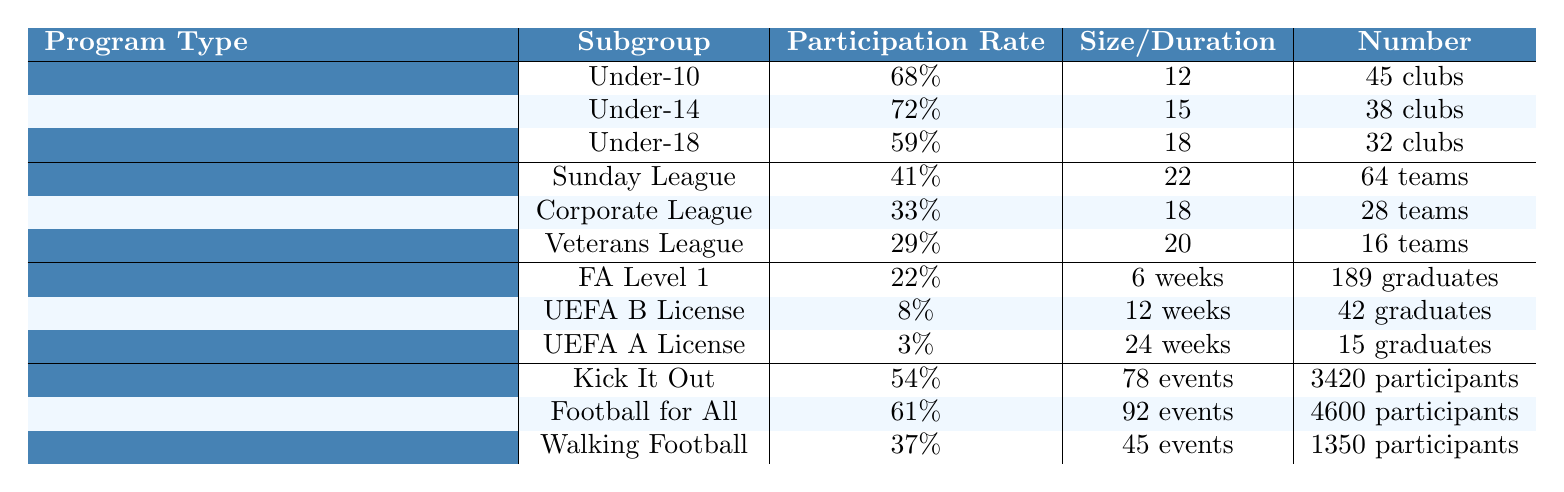What is the participation rate for Under-14 in Youth Development Academies? The table indicates that the participation rate for Under-14 is listed directly under the Youth Development Academies section. According to the table, it is 72%.
Answer: 72% Which program type has the highest participation rate for adults? Upon reviewing the Adult Recreational Leagues, the Sunday League has the highest participation rate at 41%. The rates for Corporate League and Veterans League are lower, at 33% and 29%, respectively.
Answer: Sunday League How many graduates achieved the FA Level 1 in Coaching Certification Programs? The table shows that the number of graduates for FA Level 1 is 189, as this information is explicitly listed under the Coaching Certification Programs section.
Answer: 189 What is the average participation rate of the Community Outreach Initiatives? The participation rates for the programs are Kick It Out (54%), Football for All (61%), and Walking Football (37%). To find the average, we sum these rates: 54 + 61 + 37 = 152, and then divide by 3, giving us an average of 152/3 = 50.67%.
Answer: 50.67% Which division in Adult Recreational Leagues has the lowest average team size? The table specifies the average team sizes: Sunday League 22, Corporate League 18, and Veterans League 20. Comparing these, the Corporate League has the lowest average team size of 18.
Answer: Corporate League Is the participation rate for UEFA A License higher than that of the UEFA B License? According to the table, the participation rate for UEFA A License is 3% while for UEFA B License it is 8%. Since 3% is not higher than 8%, the answer is no.
Answer: No How many total participants were reported in the Football for All program? The table specifies that the total participants in the Football for All program is 4,600, as mentioned in the Community Outreach Initiatives section specifically under the Football for All program.
Answer: 4,600 What is the difference in participation rates between Under-10 and Under-18 groups in Youth Development Academies? The participation rate for Under-10 is 68% and for Under-18 is 59%. To find the difference, we subtract the two rates: 68% - 59% = 9%.
Answer: 9% Which program type has the least number of clubs associated with it? In the Youth Development Academies section, Under-18 has 32 clubs. In the Adult Recreational Leagues, there are no clubs listed since it presents team information. The Coaching Certification Programs also lists graduates instead. Hence, Youth Development Academies have the least with 32 clubs.
Answer: Youth Development Academies How many total events were conducted in Community Outreach Initiatives? The number of events for the three programs included are Kick It Out (78), Football for All (92), and Walking Football (45). To get the total, we sum them up: 78 + 92 + 45 = 215 events.
Answer: 215 